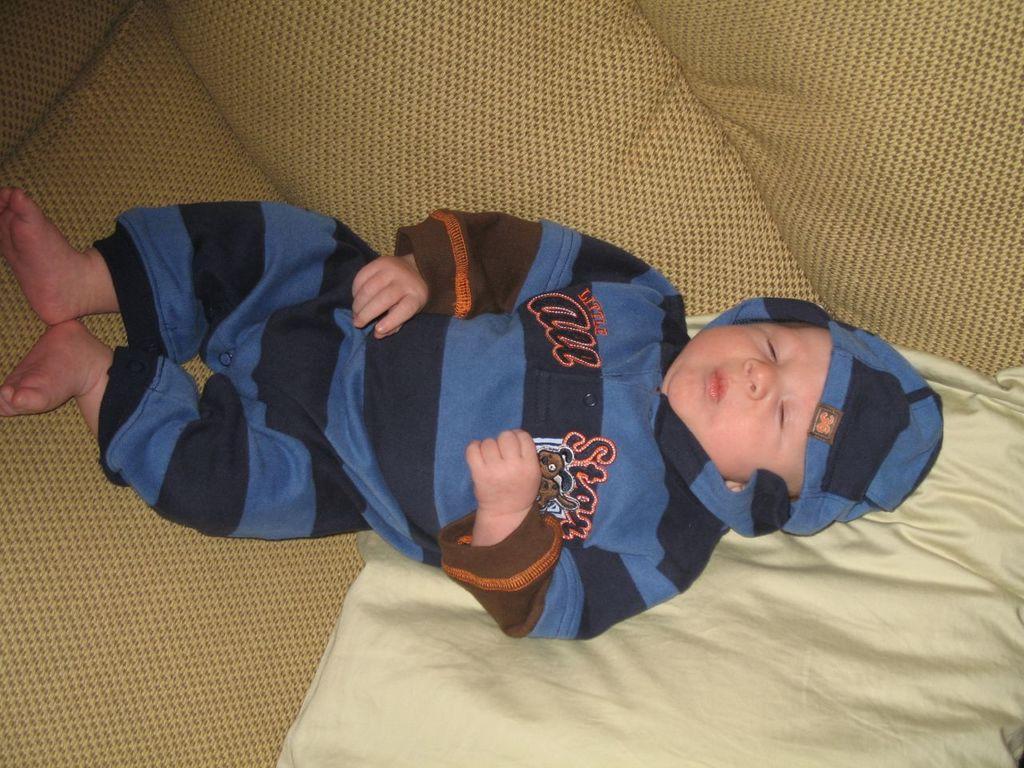Can you describe this image briefly? In this image, we can see a baby lying on the bed and we can see a bed sheet. 